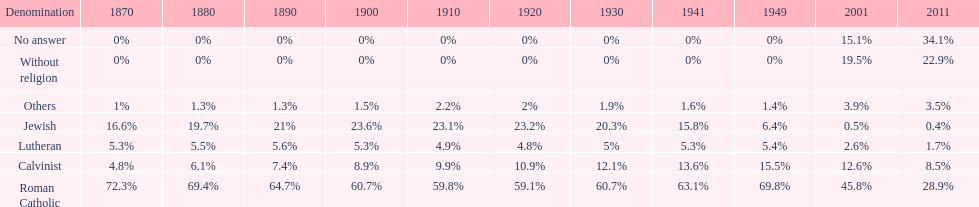What is the total percentage of people who identified as religious in 2011? 43%. 